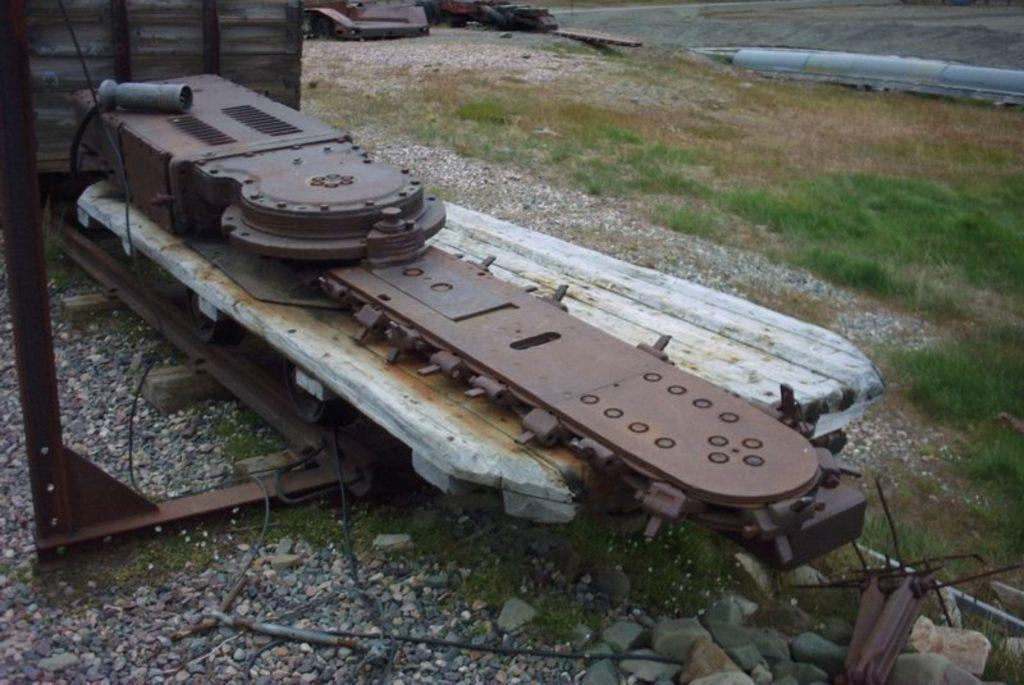What is the main object in the center of the image? There is a wooden box in the center of the image. What else can be seen in the center of the image? Metal tools are present in the center of the image. What type of natural environment is visible in the image? Grass is visible in the image. What other materials are present in the image? Stones are present in the image. What can be seen in the background of the image? In the background, there are tools visible, as well as other objects. What type of pain can be seen on the wooden object in the image? There is no indication of pain on the wooden object in the image. 